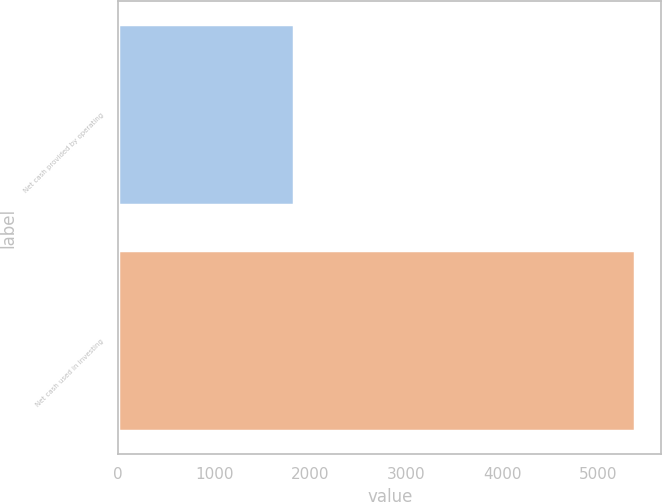<chart> <loc_0><loc_0><loc_500><loc_500><bar_chart><fcel>Net cash provided by operating<fcel>Net cash used in investing<nl><fcel>1827<fcel>5384<nl></chart> 